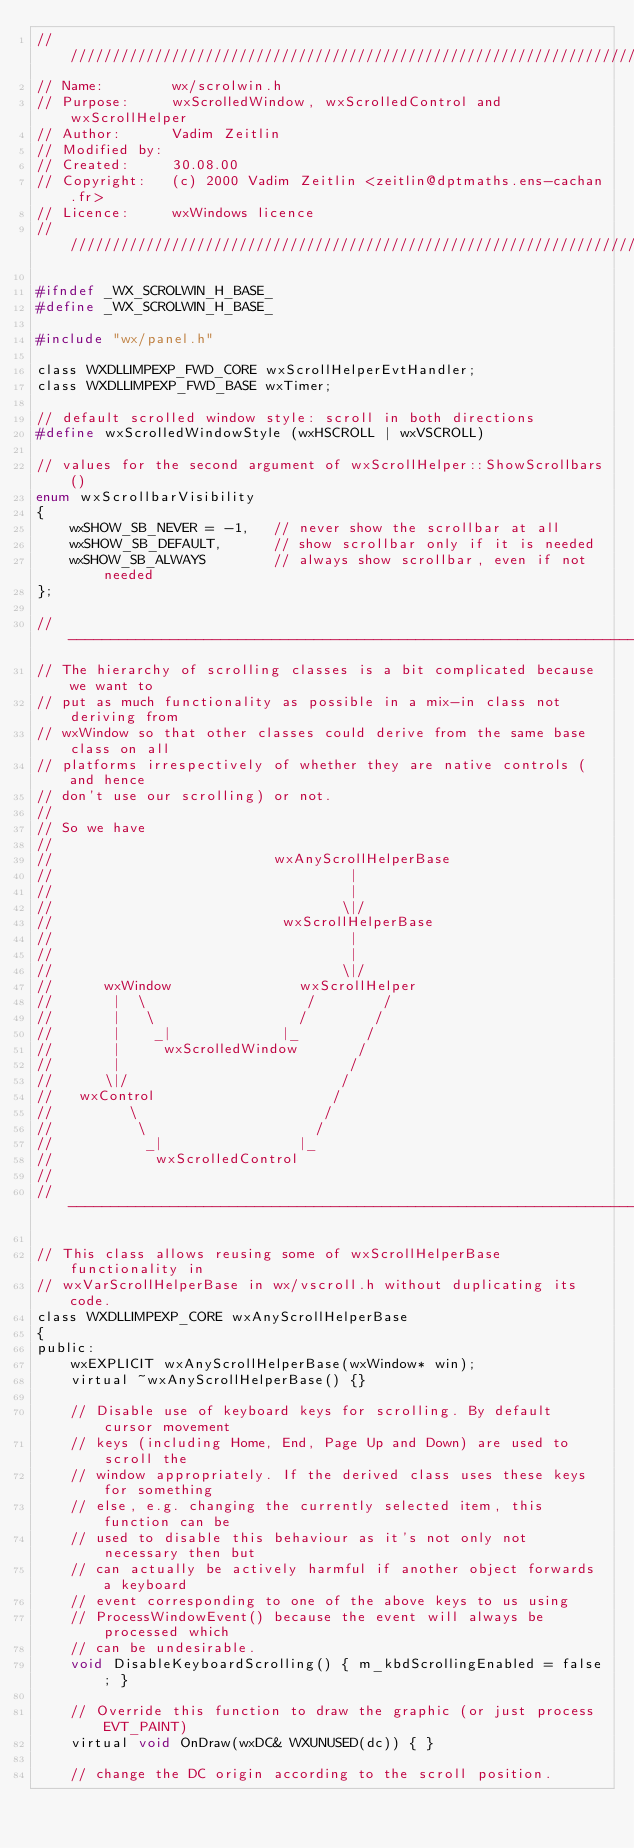Convert code to text. <code><loc_0><loc_0><loc_500><loc_500><_C_>/////////////////////////////////////////////////////////////////////////////
// Name:        wx/scrolwin.h
// Purpose:     wxScrolledWindow, wxScrolledControl and wxScrollHelper
// Author:      Vadim Zeitlin
// Modified by:
// Created:     30.08.00
// Copyright:   (c) 2000 Vadim Zeitlin <zeitlin@dptmaths.ens-cachan.fr>
// Licence:     wxWindows licence
/////////////////////////////////////////////////////////////////////////////

#ifndef _WX_SCROLWIN_H_BASE_
#define _WX_SCROLWIN_H_BASE_

#include "wx/panel.h"

class WXDLLIMPEXP_FWD_CORE wxScrollHelperEvtHandler;
class WXDLLIMPEXP_FWD_BASE wxTimer;

// default scrolled window style: scroll in both directions
#define wxScrolledWindowStyle (wxHSCROLL | wxVSCROLL)

// values for the second argument of wxScrollHelper::ShowScrollbars()
enum wxScrollbarVisibility
{
    wxSHOW_SB_NEVER = -1,   // never show the scrollbar at all
    wxSHOW_SB_DEFAULT,      // show scrollbar only if it is needed
    wxSHOW_SB_ALWAYS        // always show scrollbar, even if not needed
};

// ----------------------------------------------------------------------------
// The hierarchy of scrolling classes is a bit complicated because we want to
// put as much functionality as possible in a mix-in class not deriving from
// wxWindow so that other classes could derive from the same base class on all
// platforms irrespectively of whether they are native controls (and hence
// don't use our scrolling) or not.
//
// So we have
//
//                          wxAnyScrollHelperBase
//                                   |
//                                   |
//                                  \|/
//                           wxScrollHelperBase
//                                   |
//                                   |
//                                  \|/
//      wxWindow               wxScrollHelper
//       |  \                   /        /
//       |   \                 /        /
//       |    _|             |_        /
//       |     wxScrolledWindow       /
//       |                           /
//      \|/                         /
//   wxControl                     /
//         \                      /
//          \                    /
//           _|                |_
//            wxScrolledControl
//
// ----------------------------------------------------------------------------

// This class allows reusing some of wxScrollHelperBase functionality in
// wxVarScrollHelperBase in wx/vscroll.h without duplicating its code.
class WXDLLIMPEXP_CORE wxAnyScrollHelperBase
{
public:
    wxEXPLICIT wxAnyScrollHelperBase(wxWindow* win);
    virtual ~wxAnyScrollHelperBase() {}

    // Disable use of keyboard keys for scrolling. By default cursor movement
    // keys (including Home, End, Page Up and Down) are used to scroll the
    // window appropriately. If the derived class uses these keys for something
    // else, e.g. changing the currently selected item, this function can be
    // used to disable this behaviour as it's not only not necessary then but
    // can actually be actively harmful if another object forwards a keyboard
    // event corresponding to one of the above keys to us using
    // ProcessWindowEvent() because the event will always be processed which
    // can be undesirable.
    void DisableKeyboardScrolling() { m_kbdScrollingEnabled = false; }

    // Override this function to draw the graphic (or just process EVT_PAINT)
    virtual void OnDraw(wxDC& WXUNUSED(dc)) { }

    // change the DC origin according to the scroll position.</code> 